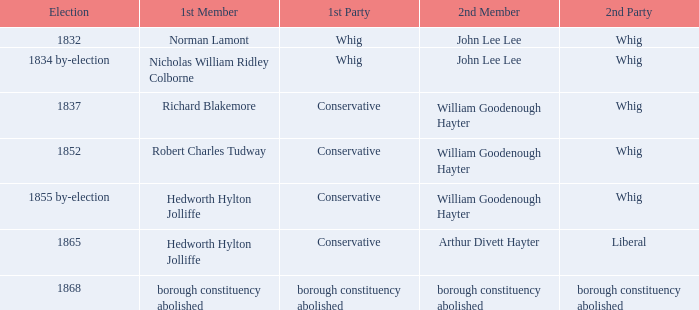What is the political affiliation of the second member arthur divett hayter when the first party is conservative? Liberal. 